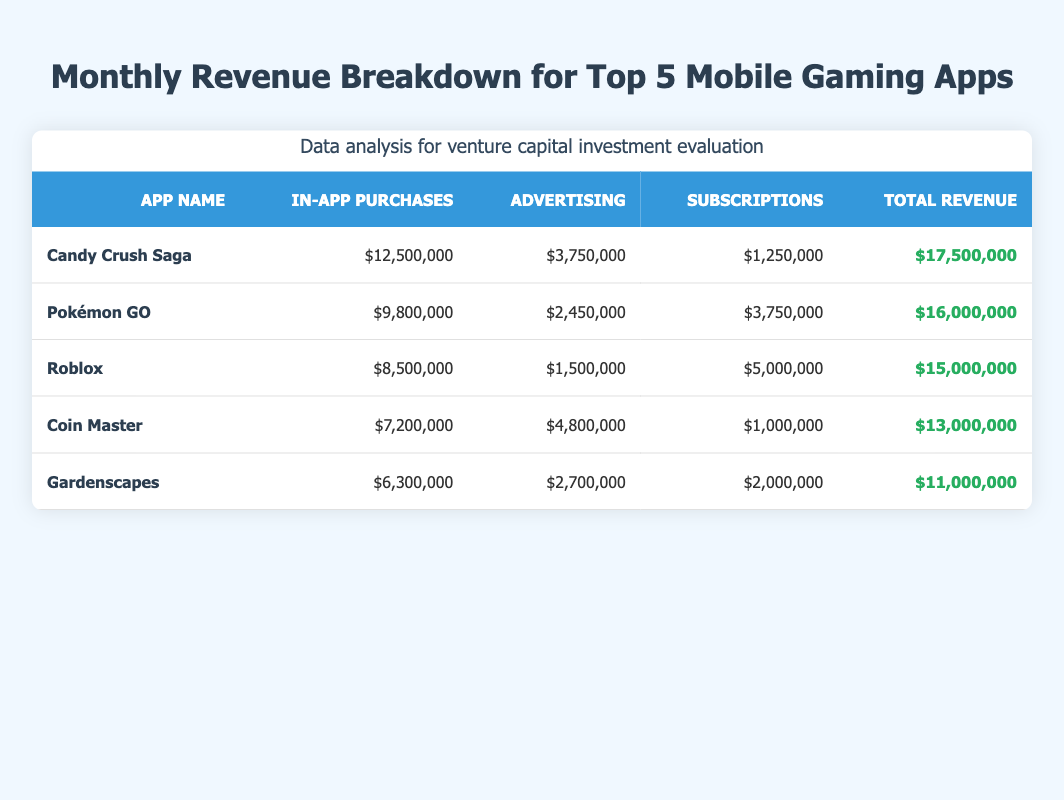What is the total revenue for Candy Crush Saga? The total revenue for Candy Crush Saga is listed in the table under the "Total Revenue" column, which shows $17,500,000.
Answer: $17,500,000 Which app generated the highest revenue from in-app purchases? By comparing the values in the "In-App Purchases" column, Candy Crush Saga has the highest at $12,500,000.
Answer: $12,500,000 Is the total revenue for Gardenscapes greater than that for Coin Master? Gardenscapes has a total revenue of $11,000,000, while Coin Master has $13,000,000. Since $11,000,000 is less than $13,000,000, the statement is false.
Answer: No What is the combined total revenue of Pokémon GO and Roblox? The total revenue of Pokémon GO is $16,000,000 and Roblox is $15,000,000. Adding them together: $16,000,000 + $15,000,000 equals $31,000,000.
Answer: $31,000,000 Which app has the highest revenue from subscriptions? In the "Subscriptions" column, Roblox shows the highest amount at $5,000,000, making it the leader in that category.
Answer: $5,000,000 What percentage of total revenue for Coin Master comes from advertising? Coin Master's total revenue is $13,000,000, and its advertising revenue is $4,800,000. To find the percentage: (4,800,000 / 13,000,000) * 100 equals approximately 36.92%.
Answer: 36.92% Is it true that the total revenue for all five apps combined exceeds $80 million? Calculating the total revenue: $17,500,000 + $16,000,000 + $15,000,000 + $13,000,000 + $11,000,000 equals $72,500,000, which does not exceed $80 million. Thus, the statement is false.
Answer: No What is the average revenue from in-app purchases for the top 5 apps? Summing the in-app purchase revenues: $12,500,000 + $9,800,000 + $8,500,000 + $7,200,000 + $6,300,000 equals $44,300,000. Dividing by 5 gives an average of $8,860,000.
Answer: $8,860,000 